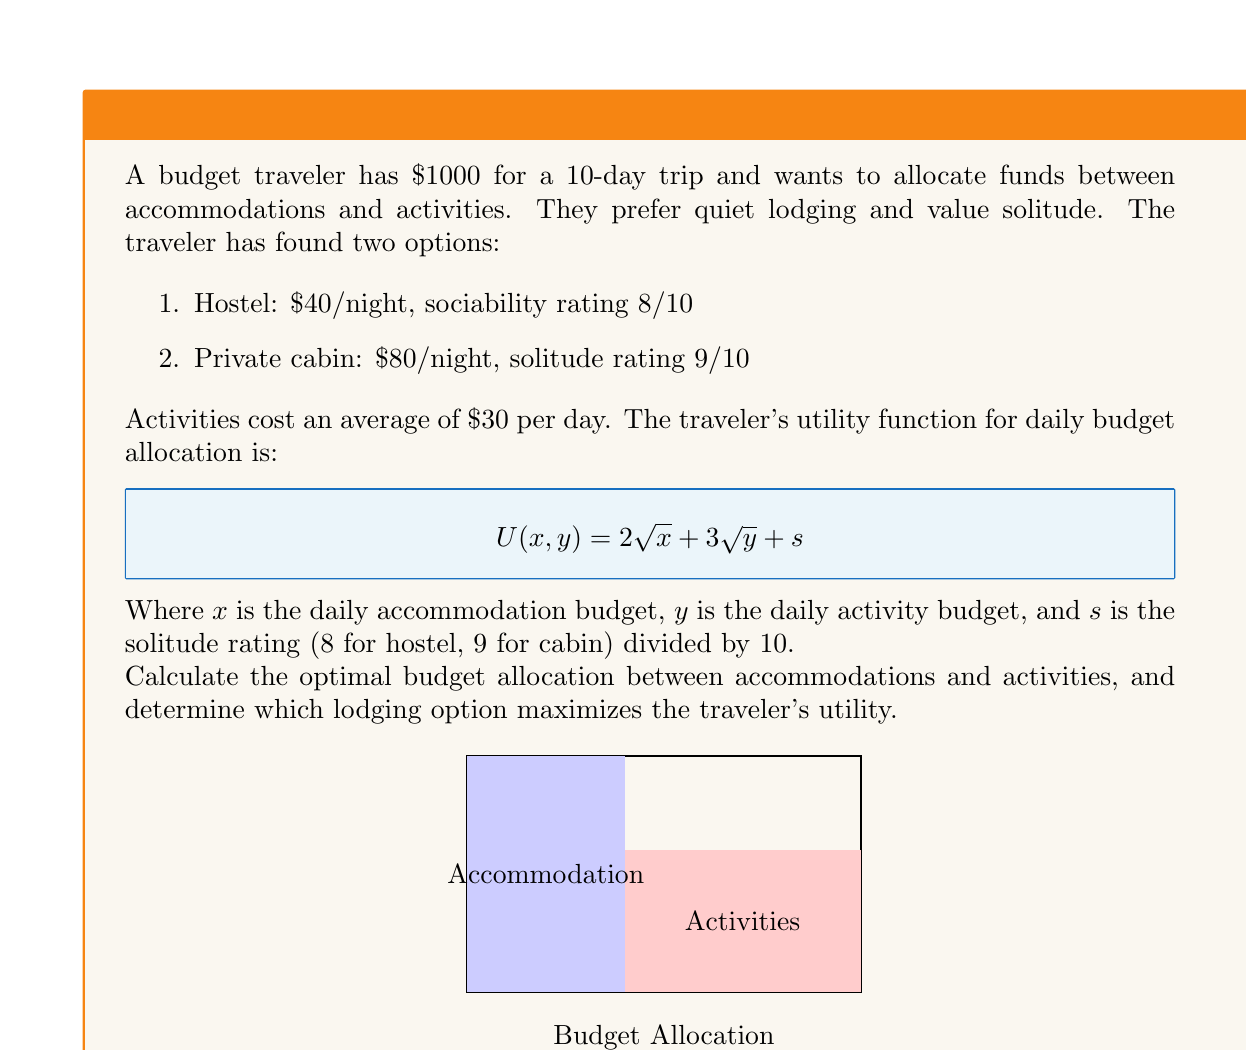Can you answer this question? Let's approach this problem step-by-step:

1) First, we need to calculate the daily budget:
   $\frac{1000}{10} = $100 per day

2) For each lodging option, we'll calculate the utility:

   Hostel:
   $x = 40, y = 60, s = 0.8$
   $U_h(40,60) = 2\sqrt{40} + 3\sqrt{60} + 0.8$
   $= 2(6.32) + 3(7.75) + 0.8$
   $= 12.64 + 23.25 + 0.8 = 36.69$

   Cabin:
   $x = 80, y = 20, s = 0.9$
   $U_c(80,20) = 2\sqrt{80} + 3\sqrt{20} + 0.9$
   $= 2(8.94) + 3(4.47) + 0.9$
   $= 17.88 + 13.41 + 0.9 = 32.19$

3) To find the optimal allocation for the cabin option, we need to maximize:
   $U(x,y) = 2\sqrt{x} + 3\sqrt{y} + 0.9$
   Subject to the constraint: $x + y = 100$

4) We can use the method of Lagrange multipliers:
   $L(x,y,\lambda) = 2\sqrt{x} + 3\sqrt{y} + 0.9 + \lambda(100-x-y)$

5) Taking partial derivatives and setting them to zero:
   $\frac{\partial L}{\partial x} = \frac{1}{\sqrt{x}} - \lambda = 0$
   $\frac{\partial L}{\partial y} = \frac{3}{2\sqrt{y}} - \lambda = 0$
   $\frac{\partial L}{\partial \lambda} = 100 - x - y = 0$

6) From the first two equations:
   $\frac{1}{\sqrt{x}} = \frac{3}{2\sqrt{y}}$
   $\frac{4x}{9} = y$

7) Substituting into the constraint:
   $x + \frac{4x}{9} = 100$
   $\frac{13x}{9} = 100$
   $x = \frac{900}{13} \approx 69.23$
   $y = 100 - 69.23 = 30.77$

8) The utility for this optimal allocation is:
   $U_o(69.23,30.77) = 2\sqrt{69.23} + 3\sqrt{30.77} + 0.9$
   $= 2(8.32) + 3(5.55) + 0.9$
   $= 16.64 + 16.65 + 0.9 = 34.19$

9) Comparing utilities:
   Hostel: 36.69
   Cabin (initial): 32.19
   Cabin (optimal): 34.19
Answer: Hostel with $40 for accommodation and $60 for activities per day, total utility 36.69. 